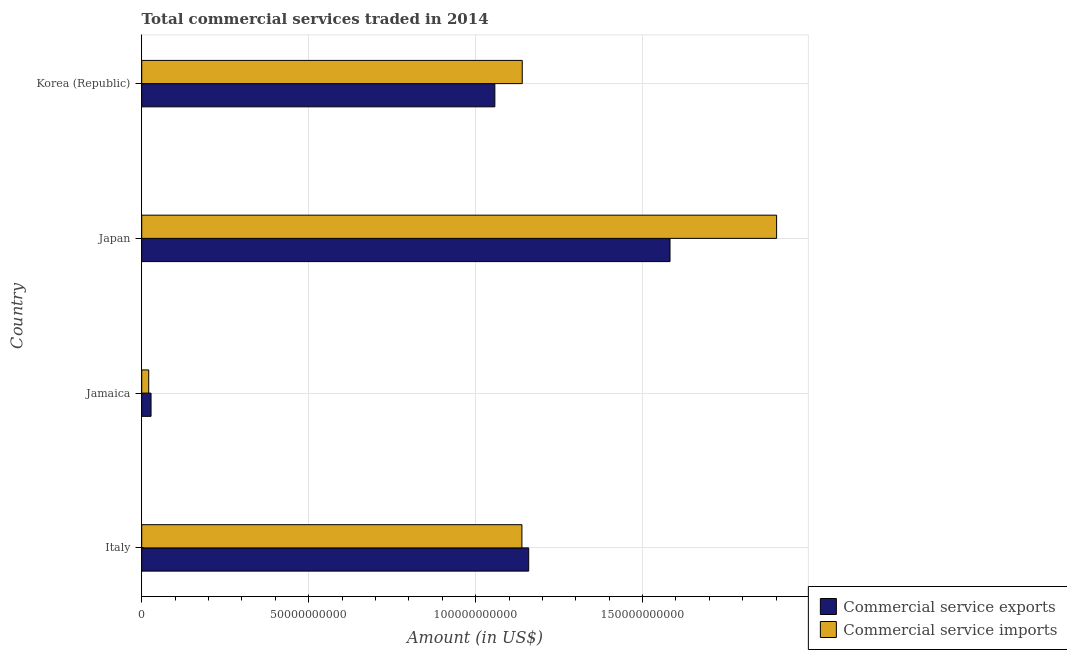How many groups of bars are there?
Your answer should be very brief. 4. Are the number of bars per tick equal to the number of legend labels?
Keep it short and to the point. Yes. How many bars are there on the 4th tick from the top?
Keep it short and to the point. 2. How many bars are there on the 1st tick from the bottom?
Your answer should be compact. 2. What is the label of the 3rd group of bars from the top?
Your answer should be compact. Jamaica. What is the amount of commercial service imports in Japan?
Make the answer very short. 1.90e+11. Across all countries, what is the maximum amount of commercial service imports?
Provide a short and direct response. 1.90e+11. Across all countries, what is the minimum amount of commercial service imports?
Ensure brevity in your answer.  2.10e+09. In which country was the amount of commercial service imports maximum?
Ensure brevity in your answer.  Japan. In which country was the amount of commercial service exports minimum?
Your response must be concise. Jamaica. What is the total amount of commercial service imports in the graph?
Give a very brief answer. 4.20e+11. What is the difference between the amount of commercial service imports in Japan and that in Korea (Republic)?
Offer a very short reply. 7.62e+1. What is the difference between the amount of commercial service imports in Korea (Republic) and the amount of commercial service exports in Italy?
Ensure brevity in your answer.  -1.93e+09. What is the average amount of commercial service imports per country?
Your answer should be compact. 1.05e+11. What is the difference between the amount of commercial service exports and amount of commercial service imports in Jamaica?
Your response must be concise. 6.96e+08. In how many countries, is the amount of commercial service imports greater than 180000000000 US$?
Offer a very short reply. 1. What is the ratio of the amount of commercial service imports in Jamaica to that in Japan?
Provide a short and direct response. 0.01. What is the difference between the highest and the second highest amount of commercial service exports?
Your answer should be compact. 4.23e+1. What is the difference between the highest and the lowest amount of commercial service exports?
Make the answer very short. 1.55e+11. In how many countries, is the amount of commercial service exports greater than the average amount of commercial service exports taken over all countries?
Your answer should be compact. 3. Is the sum of the amount of commercial service imports in Italy and Jamaica greater than the maximum amount of commercial service exports across all countries?
Make the answer very short. No. What does the 2nd bar from the top in Japan represents?
Offer a terse response. Commercial service exports. What does the 1st bar from the bottom in Korea (Republic) represents?
Offer a terse response. Commercial service exports. How many bars are there?
Keep it short and to the point. 8. Are all the bars in the graph horizontal?
Provide a succinct answer. Yes. What is the difference between two consecutive major ticks on the X-axis?
Your response must be concise. 5.00e+1. Does the graph contain any zero values?
Give a very brief answer. No. Does the graph contain grids?
Offer a very short reply. Yes. Where does the legend appear in the graph?
Make the answer very short. Bottom right. How many legend labels are there?
Ensure brevity in your answer.  2. What is the title of the graph?
Keep it short and to the point. Total commercial services traded in 2014. Does "Travel Items" appear as one of the legend labels in the graph?
Your answer should be compact. No. What is the label or title of the Y-axis?
Offer a terse response. Country. What is the Amount (in US$) in Commercial service exports in Italy?
Provide a short and direct response. 1.16e+11. What is the Amount (in US$) in Commercial service imports in Italy?
Ensure brevity in your answer.  1.14e+11. What is the Amount (in US$) in Commercial service exports in Jamaica?
Keep it short and to the point. 2.79e+09. What is the Amount (in US$) in Commercial service imports in Jamaica?
Provide a succinct answer. 2.10e+09. What is the Amount (in US$) in Commercial service exports in Japan?
Make the answer very short. 1.58e+11. What is the Amount (in US$) in Commercial service imports in Japan?
Your answer should be very brief. 1.90e+11. What is the Amount (in US$) in Commercial service exports in Korea (Republic)?
Ensure brevity in your answer.  1.06e+11. What is the Amount (in US$) in Commercial service imports in Korea (Republic)?
Provide a short and direct response. 1.14e+11. Across all countries, what is the maximum Amount (in US$) of Commercial service exports?
Your answer should be compact. 1.58e+11. Across all countries, what is the maximum Amount (in US$) in Commercial service imports?
Your answer should be compact. 1.90e+11. Across all countries, what is the minimum Amount (in US$) in Commercial service exports?
Offer a terse response. 2.79e+09. Across all countries, what is the minimum Amount (in US$) in Commercial service imports?
Offer a very short reply. 2.10e+09. What is the total Amount (in US$) in Commercial service exports in the graph?
Offer a very short reply. 3.83e+11. What is the total Amount (in US$) in Commercial service imports in the graph?
Make the answer very short. 4.20e+11. What is the difference between the Amount (in US$) of Commercial service exports in Italy and that in Jamaica?
Your answer should be compact. 1.13e+11. What is the difference between the Amount (in US$) of Commercial service imports in Italy and that in Jamaica?
Ensure brevity in your answer.  1.12e+11. What is the difference between the Amount (in US$) of Commercial service exports in Italy and that in Japan?
Offer a very short reply. -4.23e+1. What is the difference between the Amount (in US$) in Commercial service imports in Italy and that in Japan?
Keep it short and to the point. -7.63e+1. What is the difference between the Amount (in US$) in Commercial service exports in Italy and that in Korea (Republic)?
Make the answer very short. 1.01e+1. What is the difference between the Amount (in US$) in Commercial service imports in Italy and that in Korea (Republic)?
Ensure brevity in your answer.  -9.86e+07. What is the difference between the Amount (in US$) in Commercial service exports in Jamaica and that in Japan?
Make the answer very short. -1.55e+11. What is the difference between the Amount (in US$) of Commercial service imports in Jamaica and that in Japan?
Your response must be concise. -1.88e+11. What is the difference between the Amount (in US$) of Commercial service exports in Jamaica and that in Korea (Republic)?
Give a very brief answer. -1.03e+11. What is the difference between the Amount (in US$) in Commercial service imports in Jamaica and that in Korea (Republic)?
Offer a terse response. -1.12e+11. What is the difference between the Amount (in US$) of Commercial service exports in Japan and that in Korea (Republic)?
Your answer should be compact. 5.25e+1. What is the difference between the Amount (in US$) of Commercial service imports in Japan and that in Korea (Republic)?
Your response must be concise. 7.62e+1. What is the difference between the Amount (in US$) in Commercial service exports in Italy and the Amount (in US$) in Commercial service imports in Jamaica?
Give a very brief answer. 1.14e+11. What is the difference between the Amount (in US$) of Commercial service exports in Italy and the Amount (in US$) of Commercial service imports in Japan?
Provide a short and direct response. -7.42e+1. What is the difference between the Amount (in US$) in Commercial service exports in Italy and the Amount (in US$) in Commercial service imports in Korea (Republic)?
Keep it short and to the point. 1.93e+09. What is the difference between the Amount (in US$) of Commercial service exports in Jamaica and the Amount (in US$) of Commercial service imports in Japan?
Offer a terse response. -1.87e+11. What is the difference between the Amount (in US$) in Commercial service exports in Jamaica and the Amount (in US$) in Commercial service imports in Korea (Republic)?
Give a very brief answer. -1.11e+11. What is the difference between the Amount (in US$) of Commercial service exports in Japan and the Amount (in US$) of Commercial service imports in Korea (Republic)?
Your answer should be compact. 4.43e+1. What is the average Amount (in US$) of Commercial service exports per country?
Your answer should be compact. 9.57e+1. What is the average Amount (in US$) in Commercial service imports per country?
Your response must be concise. 1.05e+11. What is the difference between the Amount (in US$) of Commercial service exports and Amount (in US$) of Commercial service imports in Italy?
Give a very brief answer. 2.03e+09. What is the difference between the Amount (in US$) of Commercial service exports and Amount (in US$) of Commercial service imports in Jamaica?
Your answer should be very brief. 6.96e+08. What is the difference between the Amount (in US$) of Commercial service exports and Amount (in US$) of Commercial service imports in Japan?
Offer a very short reply. -3.19e+1. What is the difference between the Amount (in US$) in Commercial service exports and Amount (in US$) in Commercial service imports in Korea (Republic)?
Provide a short and direct response. -8.21e+09. What is the ratio of the Amount (in US$) in Commercial service exports in Italy to that in Jamaica?
Give a very brief answer. 41.5. What is the ratio of the Amount (in US$) in Commercial service imports in Italy to that in Jamaica?
Make the answer very short. 54.31. What is the ratio of the Amount (in US$) of Commercial service exports in Italy to that in Japan?
Give a very brief answer. 0.73. What is the ratio of the Amount (in US$) of Commercial service imports in Italy to that in Japan?
Offer a very short reply. 0.6. What is the ratio of the Amount (in US$) of Commercial service exports in Italy to that in Korea (Republic)?
Offer a very short reply. 1.1. What is the ratio of the Amount (in US$) in Commercial service exports in Jamaica to that in Japan?
Give a very brief answer. 0.02. What is the ratio of the Amount (in US$) of Commercial service imports in Jamaica to that in Japan?
Ensure brevity in your answer.  0.01. What is the ratio of the Amount (in US$) in Commercial service exports in Jamaica to that in Korea (Republic)?
Ensure brevity in your answer.  0.03. What is the ratio of the Amount (in US$) in Commercial service imports in Jamaica to that in Korea (Republic)?
Ensure brevity in your answer.  0.02. What is the ratio of the Amount (in US$) in Commercial service exports in Japan to that in Korea (Republic)?
Ensure brevity in your answer.  1.5. What is the ratio of the Amount (in US$) of Commercial service imports in Japan to that in Korea (Republic)?
Keep it short and to the point. 1.67. What is the difference between the highest and the second highest Amount (in US$) in Commercial service exports?
Your answer should be compact. 4.23e+1. What is the difference between the highest and the second highest Amount (in US$) in Commercial service imports?
Give a very brief answer. 7.62e+1. What is the difference between the highest and the lowest Amount (in US$) of Commercial service exports?
Give a very brief answer. 1.55e+11. What is the difference between the highest and the lowest Amount (in US$) of Commercial service imports?
Give a very brief answer. 1.88e+11. 